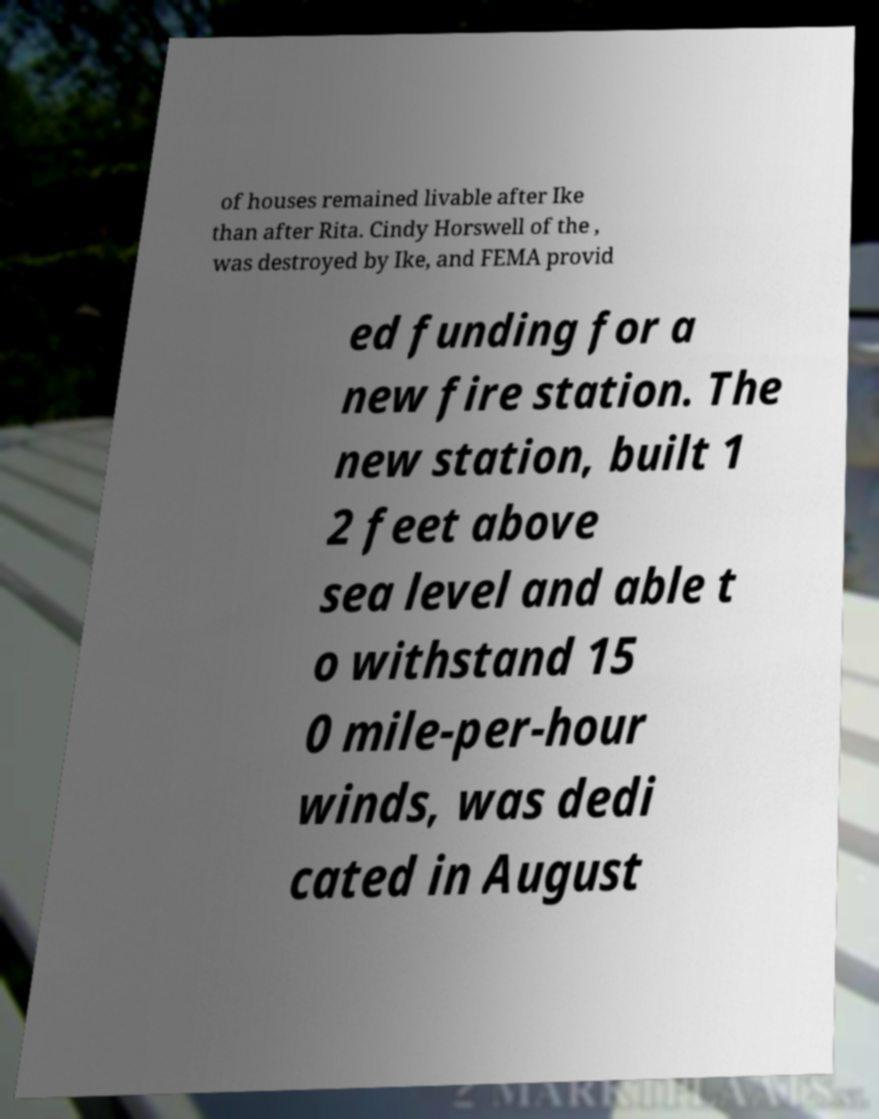Could you extract and type out the text from this image? of houses remained livable after Ike than after Rita. Cindy Horswell of the , was destroyed by Ike, and FEMA provid ed funding for a new fire station. The new station, built 1 2 feet above sea level and able t o withstand 15 0 mile-per-hour winds, was dedi cated in August 